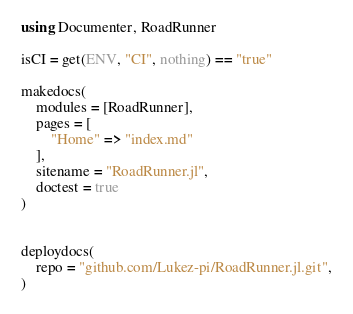Convert code to text. <code><loc_0><loc_0><loc_500><loc_500><_Julia_>using Documenter, RoadRunner

isCI = get(ENV, "CI", nothing) == "true"

makedocs(
    modules = [RoadRunner],
    pages = [
        "Home" => "index.md"
    ],
    sitename = "RoadRunner.jl",
    doctest = true
)


deploydocs(
    repo = "github.com/Lukez-pi/RoadRunner.jl.git",
)
</code> 